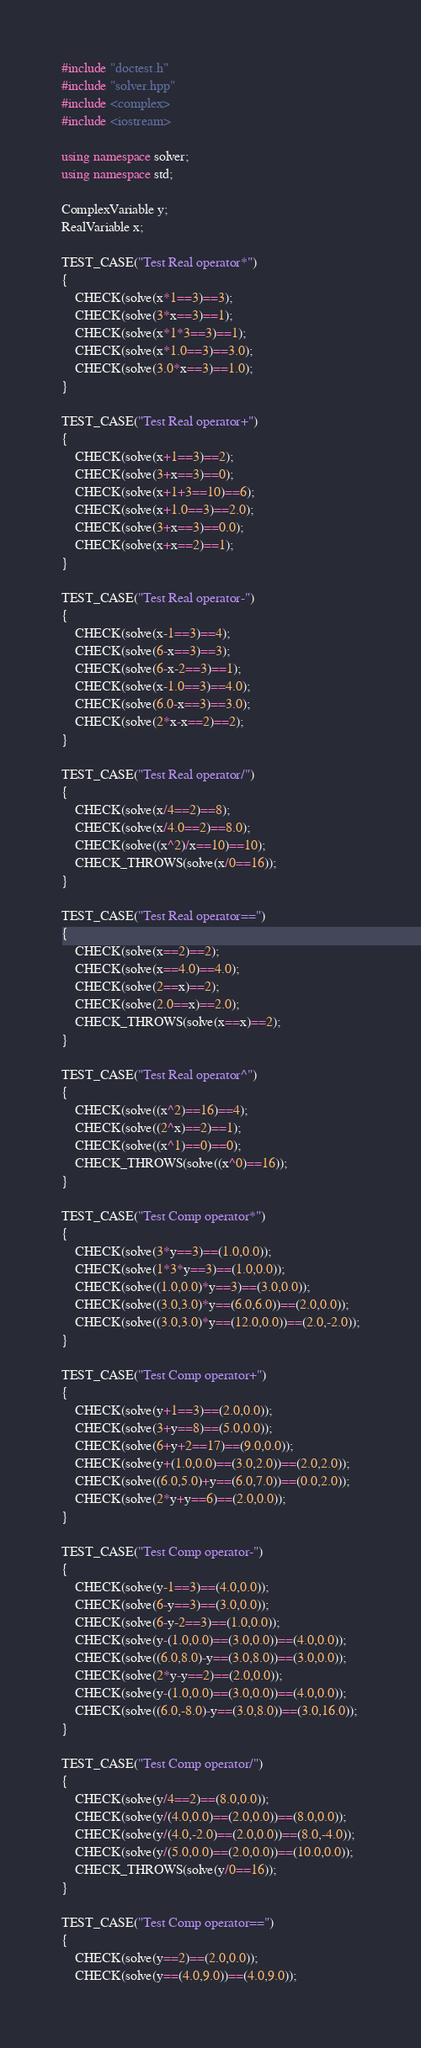Convert code to text. <code><loc_0><loc_0><loc_500><loc_500><_C++_>#include "doctest.h"
#include "solver.hpp"
#include <complex>
#include <iostream>

using namespace solver;
using namespace std;

ComplexVariable y;
RealVariable x;

TEST_CASE("Test Real operator*")
{
    CHECK(solve(x*1==3)==3);
    CHECK(solve(3*x==3)==1);
    CHECK(solve(x*1*3==3)==1);
    CHECK(solve(x*1.0==3)==3.0);
    CHECK(solve(3.0*x==3)==1.0);
}

TEST_CASE("Test Real operator+")
{
    CHECK(solve(x+1==3)==2);
    CHECK(solve(3+x==3)==0);
    CHECK(solve(x+1+3==10)==6);
    CHECK(solve(x+1.0==3)==2.0);
    CHECK(solve(3+x==3)==0.0);
    CHECK(solve(x+x==2)==1);
}

TEST_CASE("Test Real operator-")
{
    CHECK(solve(x-1==3)==4);
    CHECK(solve(6-x==3)==3);
    CHECK(solve(6-x-2==3)==1);
    CHECK(solve(x-1.0==3)==4.0);
    CHECK(solve(6.0-x==3)==3.0);
    CHECK(solve(2*x-x==2)==2);
}

TEST_CASE("Test Real operator/")
{
    CHECK(solve(x/4==2)==8);
    CHECK(solve(x/4.0==2)==8.0);
    CHECK(solve((x^2)/x==10)==10);
    CHECK_THROWS(solve(x/0==16));
}

TEST_CASE("Test Real operator==")
{
    CHECK(solve(x==2)==2);
    CHECK(solve(x==4.0)==4.0);
    CHECK(solve(2==x)==2);
    CHECK(solve(2.0==x)==2.0);
    CHECK_THROWS(solve(x==x)==2);
}

TEST_CASE("Test Real operator^")
{
    CHECK(solve((x^2)==16)==4);
    CHECK(solve((2^x)==2)==1);
    CHECK(solve((x^1)==0)==0);
    CHECK_THROWS(solve((x^0)==16));
}

TEST_CASE("Test Comp operator*")
{
    CHECK(solve(3*y==3)==(1.0,0.0));
    CHECK(solve(1*3*y==3)==(1.0,0.0));
    CHECK(solve((1.0,0.0)*y==3)==(3.0,0.0));
    CHECK(solve((3.0,3.0)*y==(6.0,6.0))==(2.0,0.0));
    CHECK(solve((3.0,3.0)*y==(12.0,0.0))==(2.0,-2.0));
}

TEST_CASE("Test Comp operator+")
{
    CHECK(solve(y+1==3)==(2.0,0.0));
    CHECK(solve(3+y==8)==(5.0,0.0));
    CHECK(solve(6+y+2==17)==(9.0,0.0));
    CHECK(solve(y+(1.0,0.0)==(3.0,2.0))==(2.0,2.0));
    CHECK(solve((6.0,5.0)+y==(6.0,7.0))==(0.0,2.0));
    CHECK(solve(2*y+y==6)==(2.0,0.0));
}

TEST_CASE("Test Comp operator-")
{
    CHECK(solve(y-1==3)==(4.0,0.0));
    CHECK(solve(6-y==3)==(3.0,0.0));
    CHECK(solve(6-y-2==3)==(1.0,0.0));
    CHECK(solve(y-(1.0,0.0)==(3.0,0.0))==(4.0,0.0));
    CHECK(solve((6.0,8.0)-y==(3.0,8.0))==(3.0,0.0));
    CHECK(solve(2*y-y==2)==(2.0,0.0));
    CHECK(solve(y-(1.0,0.0)==(3.0,0.0))==(4.0,0.0));
    CHECK(solve((6.0,-8.0)-y==(3.0,8.0))==(3.0,16.0));
}

TEST_CASE("Test Comp operator/")
{
    CHECK(solve(y/4==2)==(8.0,0.0));
    CHECK(solve(y/(4.0,0.0)==(2.0,0.0))==(8.0,0.0));
    CHECK(solve(y/(4.0,-2.0)==(2.0,0.0))==(8.0,-4.0));
    CHECK(solve(y/(5.0,0.0)==(2.0,0.0))==(10.0,0.0));
    CHECK_THROWS(solve(y/0==16));
}

TEST_CASE("Test Comp operator==")
{
    CHECK(solve(y==2)==(2.0,0.0));
    CHECK(solve(y==(4.0,9.0))==(4.0,9.0));</code> 